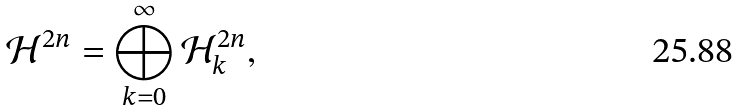Convert formula to latex. <formula><loc_0><loc_0><loc_500><loc_500>\mathcal { H } ^ { 2 n } = \bigoplus _ { k = 0 } ^ { \infty } \mathcal { H } _ { k } ^ { 2 n } ,</formula> 